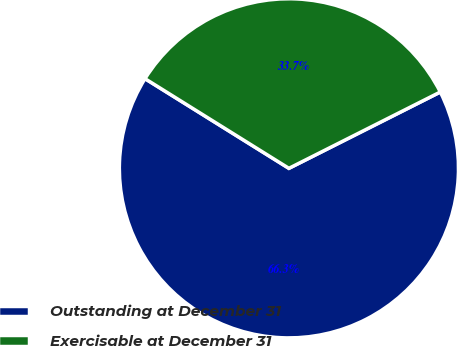Convert chart to OTSL. <chart><loc_0><loc_0><loc_500><loc_500><pie_chart><fcel>Outstanding at December 31<fcel>Exercisable at December 31<nl><fcel>66.3%<fcel>33.7%<nl></chart> 